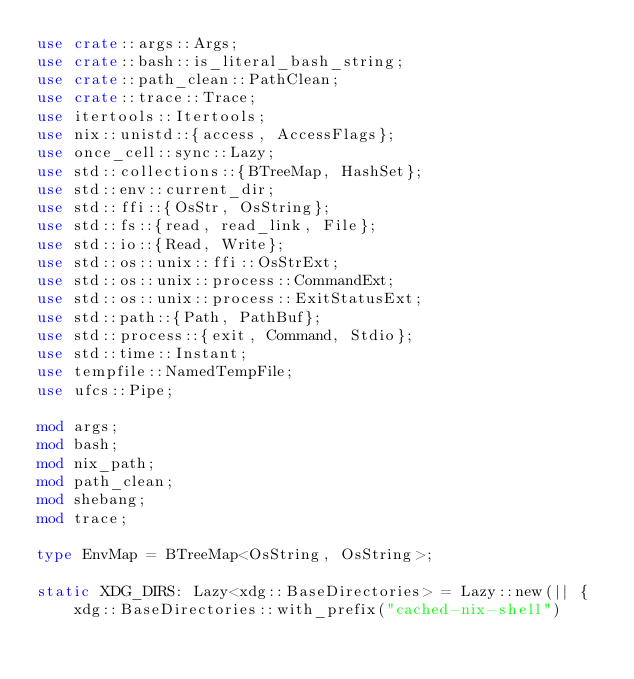Convert code to text. <code><loc_0><loc_0><loc_500><loc_500><_Rust_>use crate::args::Args;
use crate::bash::is_literal_bash_string;
use crate::path_clean::PathClean;
use crate::trace::Trace;
use itertools::Itertools;
use nix::unistd::{access, AccessFlags};
use once_cell::sync::Lazy;
use std::collections::{BTreeMap, HashSet};
use std::env::current_dir;
use std::ffi::{OsStr, OsString};
use std::fs::{read, read_link, File};
use std::io::{Read, Write};
use std::os::unix::ffi::OsStrExt;
use std::os::unix::process::CommandExt;
use std::os::unix::process::ExitStatusExt;
use std::path::{Path, PathBuf};
use std::process::{exit, Command, Stdio};
use std::time::Instant;
use tempfile::NamedTempFile;
use ufcs::Pipe;

mod args;
mod bash;
mod nix_path;
mod path_clean;
mod shebang;
mod trace;

type EnvMap = BTreeMap<OsString, OsString>;

static XDG_DIRS: Lazy<xdg::BaseDirectories> = Lazy::new(|| {
    xdg::BaseDirectories::with_prefix("cached-nix-shell")</code> 